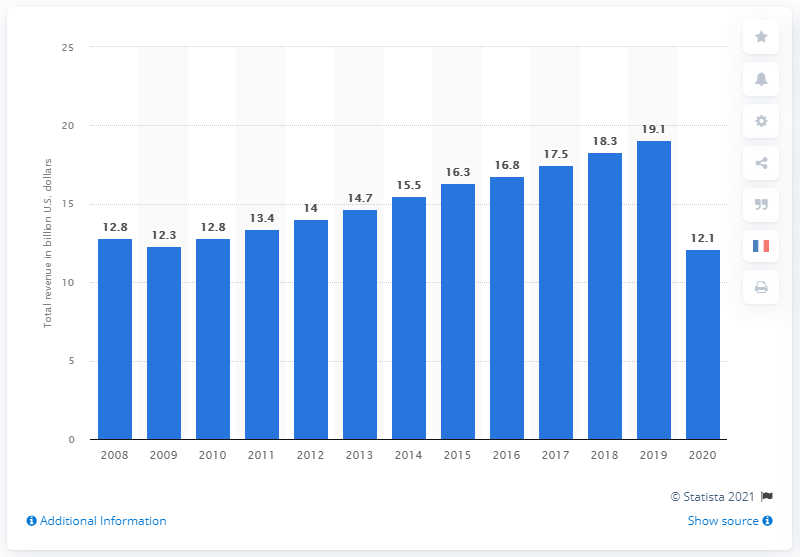Indicate a few pertinent items in this graphic. In 2020, the spa industry in the United States was worth an estimated 12.1 billion dollars. 